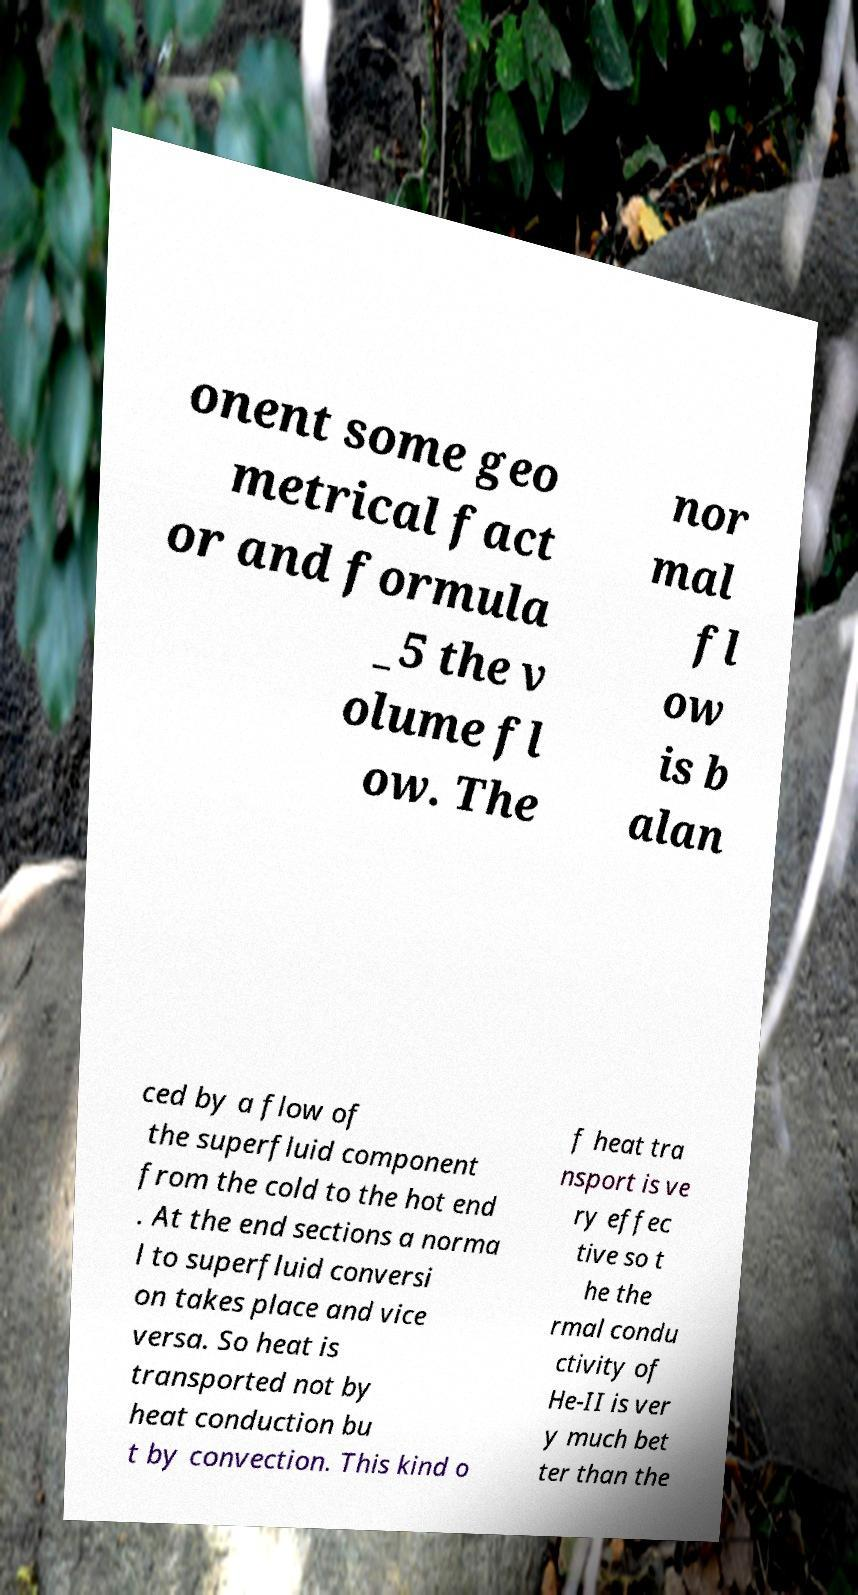Could you assist in decoding the text presented in this image and type it out clearly? onent some geo metrical fact or and formula _5 the v olume fl ow. The nor mal fl ow is b alan ced by a flow of the superfluid component from the cold to the hot end . At the end sections a norma l to superfluid conversi on takes place and vice versa. So heat is transported not by heat conduction bu t by convection. This kind o f heat tra nsport is ve ry effec tive so t he the rmal condu ctivity of He-II is ver y much bet ter than the 